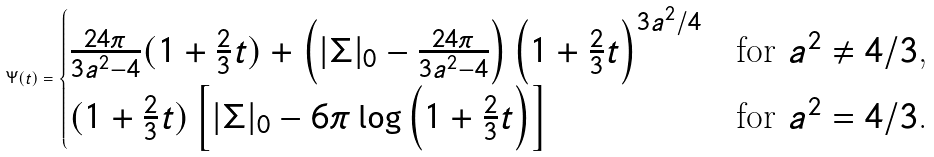Convert formula to latex. <formula><loc_0><loc_0><loc_500><loc_500>\Psi ( t ) = \begin{cases} \frac { 2 4 \pi } { 3 a ^ { 2 } - 4 } ( 1 + \frac { 2 } { 3 } t ) + \left ( | \Sigma | _ { 0 } - \frac { 2 4 \pi } { 3 a ^ { 2 } - 4 } \right ) \left ( 1 + \frac { 2 } { 3 } t \right ) ^ { 3 a ^ { 2 } / 4 } & \text {for $a^{2}\neq 4/3$,} \\ ( 1 + \frac { 2 } { 3 } t ) \left [ | \Sigma | _ { 0 } - 6 \pi \log \left ( 1 + \frac { 2 } { 3 } t \right ) \right ] & \text {for $a^{2}= 4/3$.} \end{cases}</formula> 